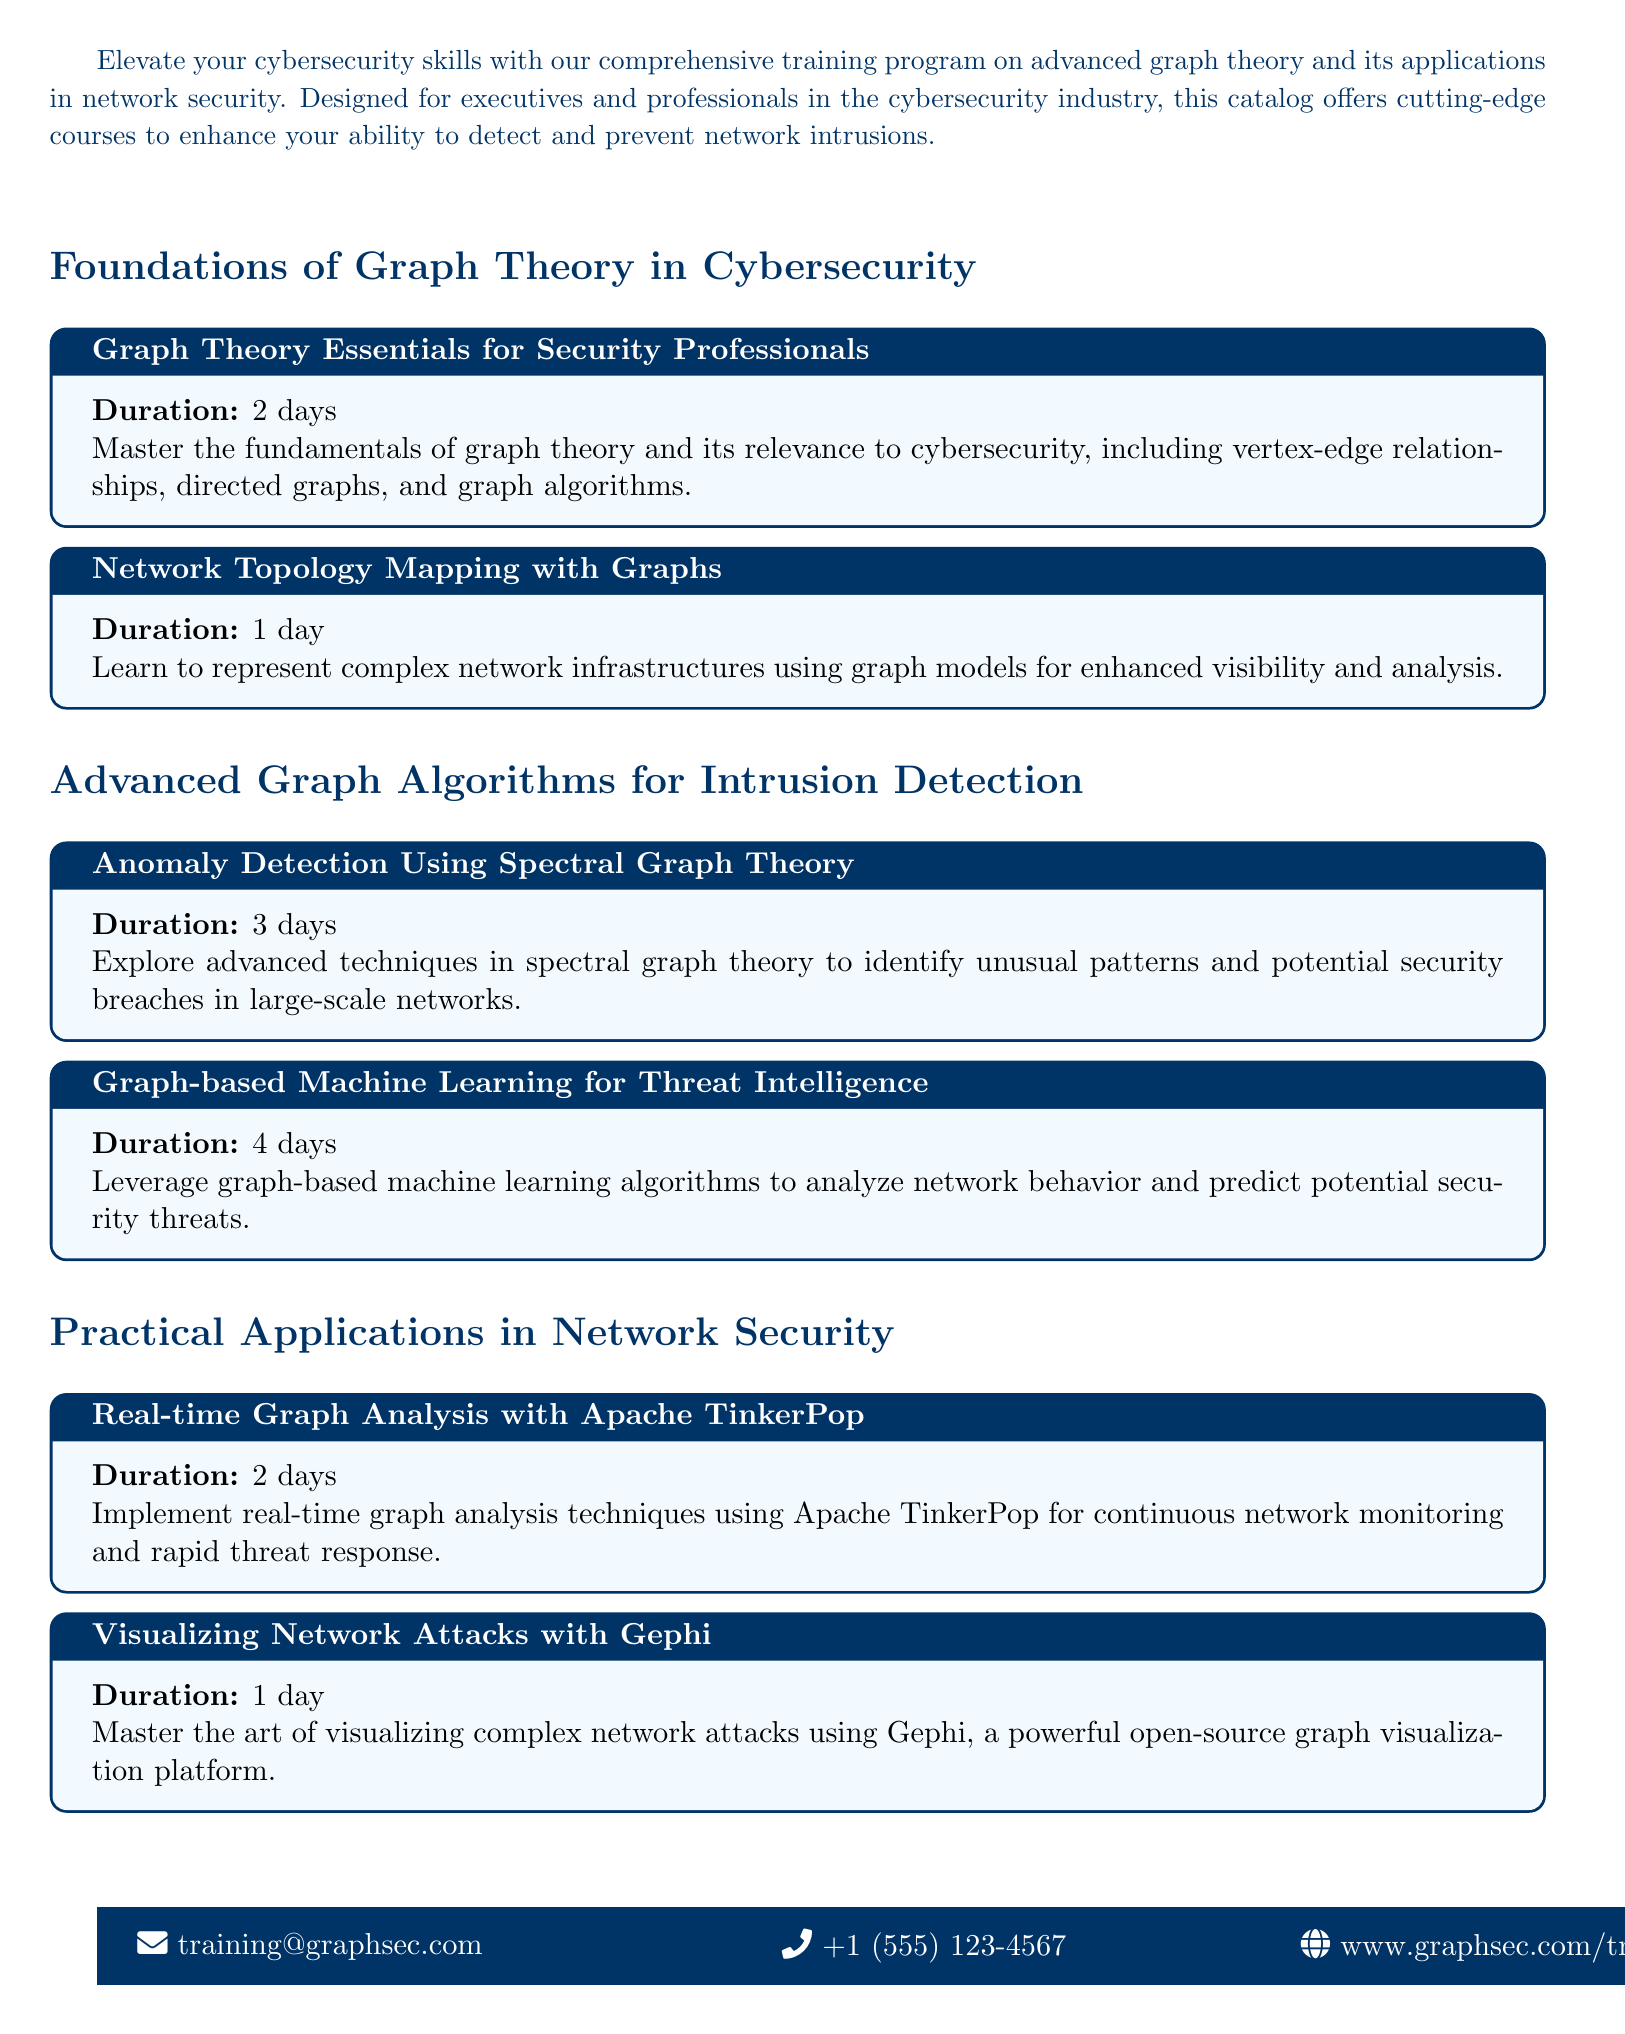What is the title of the training catalog? The title of the training catalog is prominently displayed at the top of the document.
Answer: Advanced Graph Theory for Network Security How many days is the course on Graph Theory Essentials for Security Professionals? The duration of the course is stated in the course block for Graph Theory Essentials.
Answer: 2 days What is the focus of the course Anomaly Detection Using Spectral Graph Theory? The focus of the course is detailed in its description within the training catalog.
Answer: Identify unusual patterns and potential security breaches What tool is used for visualizing network attacks in one of the courses? The course description provides information about the tool used for visualization.
Answer: Gephi What is the total duration of the courses listed under Advanced Graph Algorithms for Intrusion Detection? By adding the durations of both courses in this section, we can find the total duration.
Answer: 7 days Which course is about implementing real-time graph analysis? The course title indicates its focus on real-time graph analysis techniques.
Answer: Real-time Graph Analysis with Apache TinkerPop What is the contact email provided for inquiries? The document includes contact information at the bottom, including the email address.
Answer: training@graphsec.com How many courses focus specifically on machine learning? By reviewing the course titles, we can determine how many courses focus on machine learning.
Answer: 1 course 